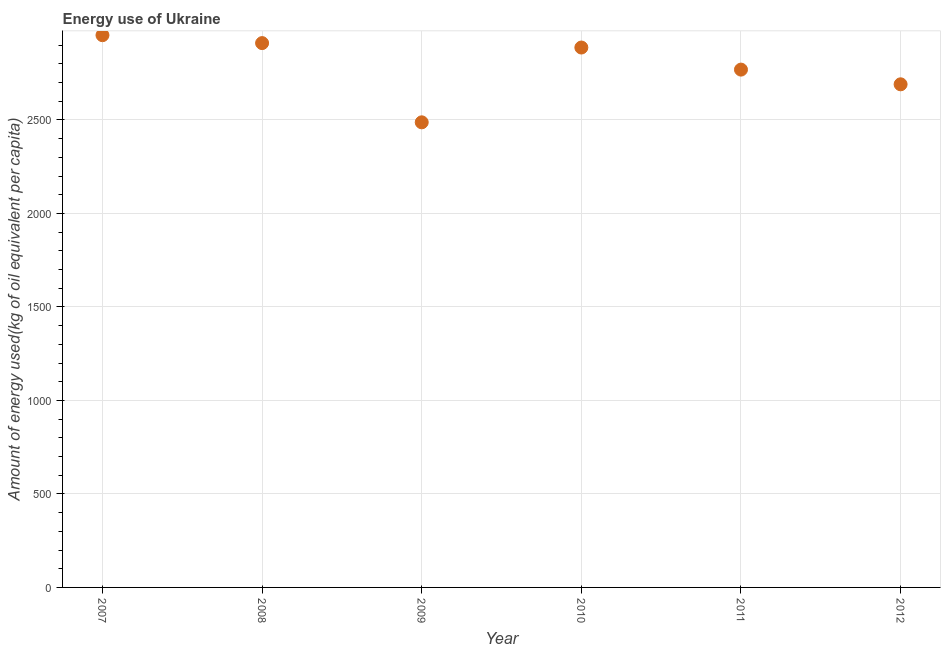What is the amount of energy used in 2011?
Give a very brief answer. 2768.92. Across all years, what is the maximum amount of energy used?
Ensure brevity in your answer.  2953.02. Across all years, what is the minimum amount of energy used?
Your answer should be very brief. 2487.04. In which year was the amount of energy used maximum?
Make the answer very short. 2007. What is the sum of the amount of energy used?
Give a very brief answer. 1.67e+04. What is the difference between the amount of energy used in 2011 and 2012?
Offer a very short reply. 78.6. What is the average amount of energy used per year?
Provide a short and direct response. 2782.82. What is the median amount of energy used?
Ensure brevity in your answer.  2827.96. What is the ratio of the amount of energy used in 2009 to that in 2011?
Your answer should be very brief. 0.9. Is the amount of energy used in 2009 less than that in 2012?
Provide a succinct answer. Yes. What is the difference between the highest and the second highest amount of energy used?
Offer a terse response. 42.36. What is the difference between the highest and the lowest amount of energy used?
Your answer should be compact. 465.98. In how many years, is the amount of energy used greater than the average amount of energy used taken over all years?
Offer a very short reply. 3. Does the amount of energy used monotonically increase over the years?
Ensure brevity in your answer.  No. Does the graph contain any zero values?
Provide a succinct answer. No. What is the title of the graph?
Ensure brevity in your answer.  Energy use of Ukraine. What is the label or title of the Y-axis?
Your answer should be compact. Amount of energy used(kg of oil equivalent per capita). What is the Amount of energy used(kg of oil equivalent per capita) in 2007?
Ensure brevity in your answer.  2953.02. What is the Amount of energy used(kg of oil equivalent per capita) in 2008?
Offer a very short reply. 2910.65. What is the Amount of energy used(kg of oil equivalent per capita) in 2009?
Give a very brief answer. 2487.04. What is the Amount of energy used(kg of oil equivalent per capita) in 2010?
Your answer should be compact. 2887. What is the Amount of energy used(kg of oil equivalent per capita) in 2011?
Make the answer very short. 2768.92. What is the Amount of energy used(kg of oil equivalent per capita) in 2012?
Your response must be concise. 2690.32. What is the difference between the Amount of energy used(kg of oil equivalent per capita) in 2007 and 2008?
Offer a very short reply. 42.36. What is the difference between the Amount of energy used(kg of oil equivalent per capita) in 2007 and 2009?
Your answer should be compact. 465.98. What is the difference between the Amount of energy used(kg of oil equivalent per capita) in 2007 and 2010?
Your answer should be very brief. 66.02. What is the difference between the Amount of energy used(kg of oil equivalent per capita) in 2007 and 2011?
Ensure brevity in your answer.  184.09. What is the difference between the Amount of energy used(kg of oil equivalent per capita) in 2007 and 2012?
Make the answer very short. 262.69. What is the difference between the Amount of energy used(kg of oil equivalent per capita) in 2008 and 2009?
Provide a succinct answer. 423.61. What is the difference between the Amount of energy used(kg of oil equivalent per capita) in 2008 and 2010?
Provide a short and direct response. 23.65. What is the difference between the Amount of energy used(kg of oil equivalent per capita) in 2008 and 2011?
Provide a short and direct response. 141.73. What is the difference between the Amount of energy used(kg of oil equivalent per capita) in 2008 and 2012?
Give a very brief answer. 220.33. What is the difference between the Amount of energy used(kg of oil equivalent per capita) in 2009 and 2010?
Offer a very short reply. -399.96. What is the difference between the Amount of energy used(kg of oil equivalent per capita) in 2009 and 2011?
Your answer should be compact. -281.89. What is the difference between the Amount of energy used(kg of oil equivalent per capita) in 2009 and 2012?
Offer a very short reply. -203.29. What is the difference between the Amount of energy used(kg of oil equivalent per capita) in 2010 and 2011?
Provide a succinct answer. 118.07. What is the difference between the Amount of energy used(kg of oil equivalent per capita) in 2010 and 2012?
Make the answer very short. 196.67. What is the difference between the Amount of energy used(kg of oil equivalent per capita) in 2011 and 2012?
Your answer should be compact. 78.6. What is the ratio of the Amount of energy used(kg of oil equivalent per capita) in 2007 to that in 2009?
Your answer should be very brief. 1.19. What is the ratio of the Amount of energy used(kg of oil equivalent per capita) in 2007 to that in 2011?
Keep it short and to the point. 1.07. What is the ratio of the Amount of energy used(kg of oil equivalent per capita) in 2007 to that in 2012?
Ensure brevity in your answer.  1.1. What is the ratio of the Amount of energy used(kg of oil equivalent per capita) in 2008 to that in 2009?
Make the answer very short. 1.17. What is the ratio of the Amount of energy used(kg of oil equivalent per capita) in 2008 to that in 2010?
Your answer should be compact. 1.01. What is the ratio of the Amount of energy used(kg of oil equivalent per capita) in 2008 to that in 2011?
Give a very brief answer. 1.05. What is the ratio of the Amount of energy used(kg of oil equivalent per capita) in 2008 to that in 2012?
Provide a short and direct response. 1.08. What is the ratio of the Amount of energy used(kg of oil equivalent per capita) in 2009 to that in 2010?
Keep it short and to the point. 0.86. What is the ratio of the Amount of energy used(kg of oil equivalent per capita) in 2009 to that in 2011?
Keep it short and to the point. 0.9. What is the ratio of the Amount of energy used(kg of oil equivalent per capita) in 2009 to that in 2012?
Your answer should be very brief. 0.92. What is the ratio of the Amount of energy used(kg of oil equivalent per capita) in 2010 to that in 2011?
Provide a short and direct response. 1.04. What is the ratio of the Amount of energy used(kg of oil equivalent per capita) in 2010 to that in 2012?
Offer a terse response. 1.07. 